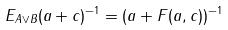Convert formula to latex. <formula><loc_0><loc_0><loc_500><loc_500>E _ { A \vee B } ( a + c ) ^ { - 1 } = ( a + F ( a , c ) ) ^ { - 1 }</formula> 